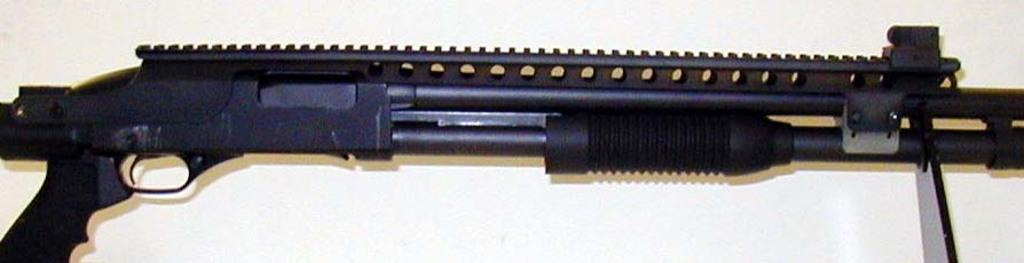What object in the image can be considered a weapon? There is a weapon in the image, but the specific type of weapon cannot be determined from the given facts. How many stars can be seen attached to the weapon in the image? There is no mention of stars in the image, so it cannot be determined if any are attached to the weapon. 